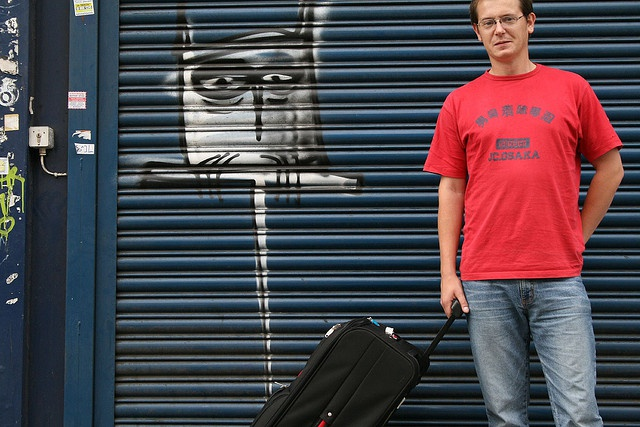Describe the objects in this image and their specific colors. I can see people in navy, brown, salmon, red, and gray tones and suitcase in navy, black, gray, white, and blue tones in this image. 